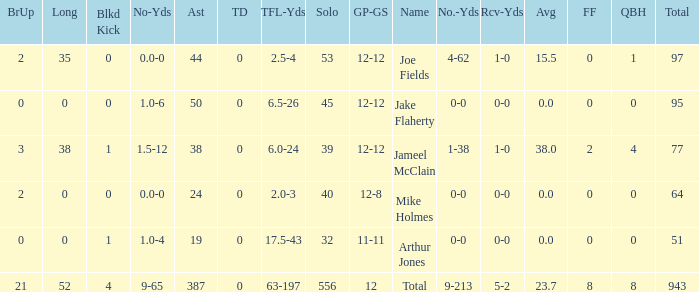How many tackle assists for the player who averages 23.7? 387.0. 